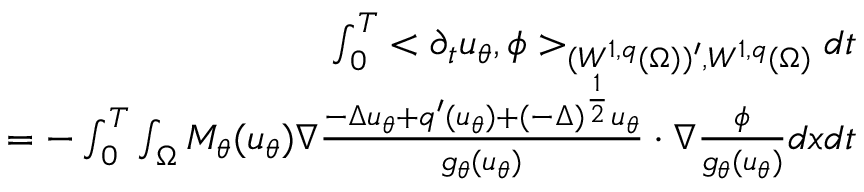Convert formula to latex. <formula><loc_0><loc_0><loc_500><loc_500>\begin{array} { r l r } & { \int _ { 0 } ^ { T } < \partial _ { t } u _ { \theta } , \phi > _ { ( W ^ { 1 , q } ( \Omega ) ) ^ { \prime } , W ^ { 1 , q } ( \Omega ) } d t } \\ & { = - \int _ { 0 } ^ { T } \int _ { \Omega } M _ { \theta } ( u _ { \theta } ) \nabla \frac { - \Delta u _ { \theta } + q ^ { \prime } ( u _ { \theta } ) + ( - \Delta ) ^ { \frac { 1 } { 2 } } u _ { \theta } } { g _ { \theta } ( u _ { \theta } ) } \cdot \nabla \frac { \phi } { g _ { \theta } ( u _ { \theta } ) } d x d t } \end{array}</formula> 